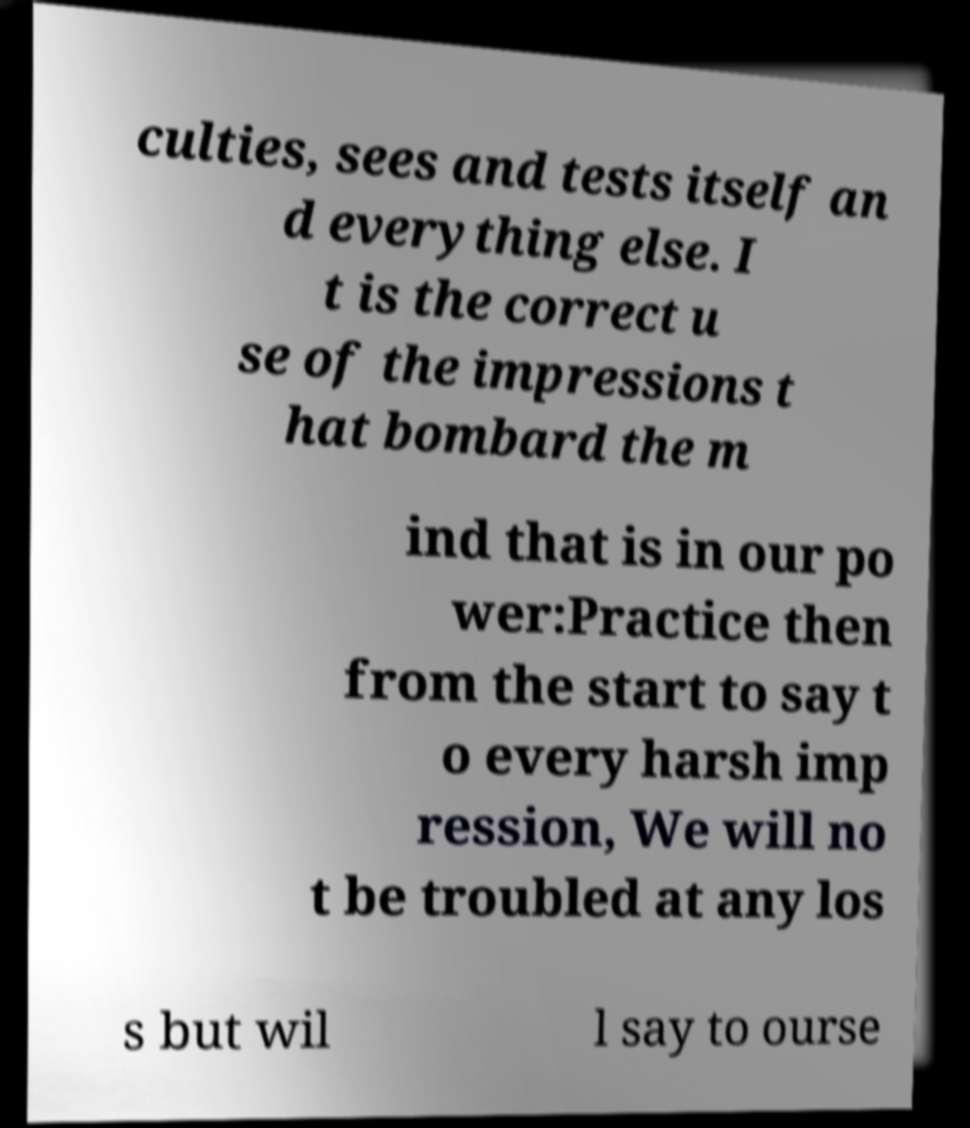Can you read and provide the text displayed in the image?This photo seems to have some interesting text. Can you extract and type it out for me? culties, sees and tests itself an d everything else. I t is the correct u se of the impressions t hat bombard the m ind that is in our po wer:Practice then from the start to say t o every harsh imp ression, We will no t be troubled at any los s but wil l say to ourse 